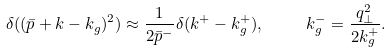Convert formula to latex. <formula><loc_0><loc_0><loc_500><loc_500>\delta ( ( \bar { p } + k - k _ { g } ) ^ { 2 } ) \approx \frac { 1 } { 2 \bar { p } ^ { - } } \delta ( k ^ { + } - k _ { g } ^ { + } ) , \quad \ k _ { g } ^ { - } = \frac { q _ { \perp } ^ { 2 } } { 2 k _ { g } ^ { + } } .</formula> 